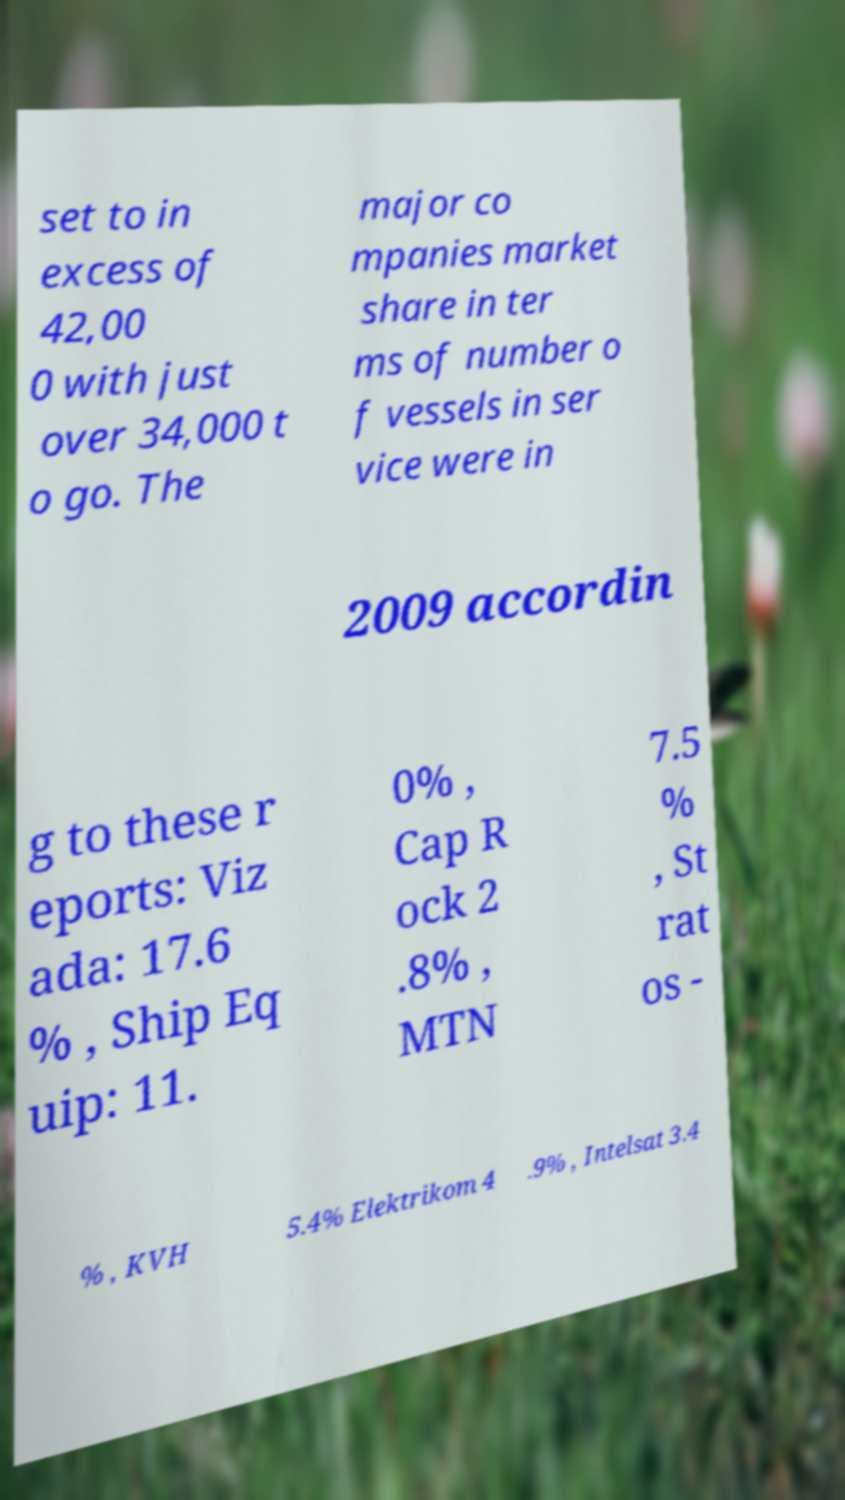Can you accurately transcribe the text from the provided image for me? set to in excess of 42,00 0 with just over 34,000 t o go. The major co mpanies market share in ter ms of number o f vessels in ser vice were in 2009 accordin g to these r eports: Viz ada: 17.6 % , Ship Eq uip: 11. 0% , Cap R ock 2 .8% , MTN 7.5 % , St rat os - % , KVH 5.4% Elektrikom 4 .9% , Intelsat 3.4 